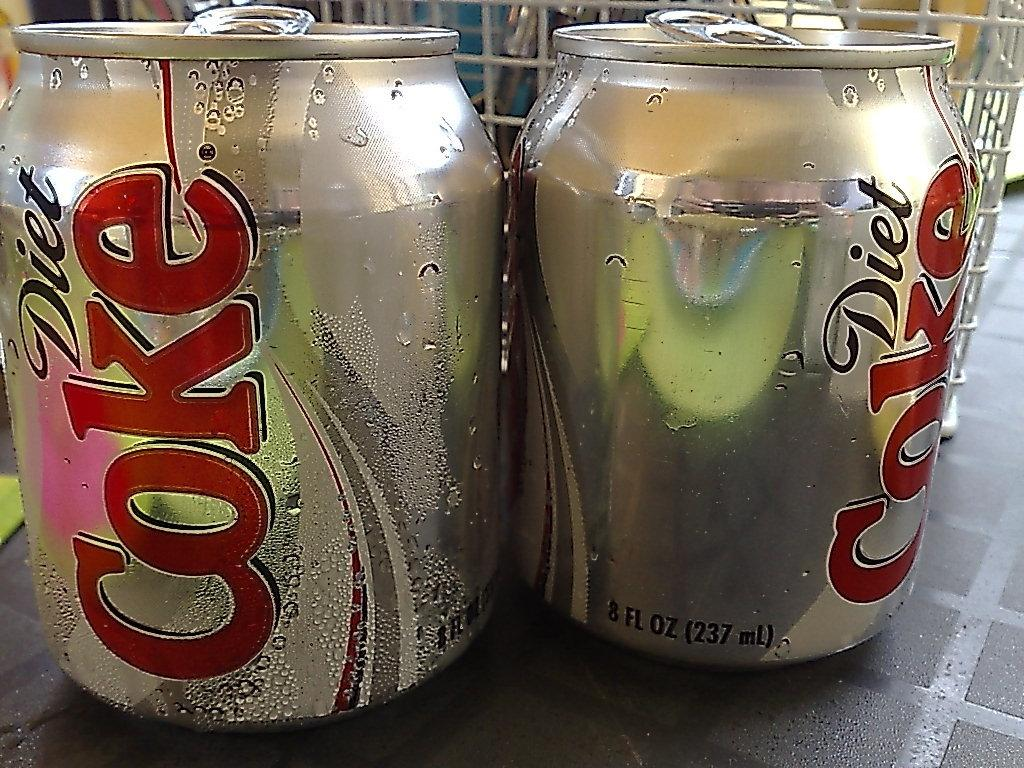<image>
Relay a brief, clear account of the picture shown. Two cans of Diet Coke sitting next to each other. 